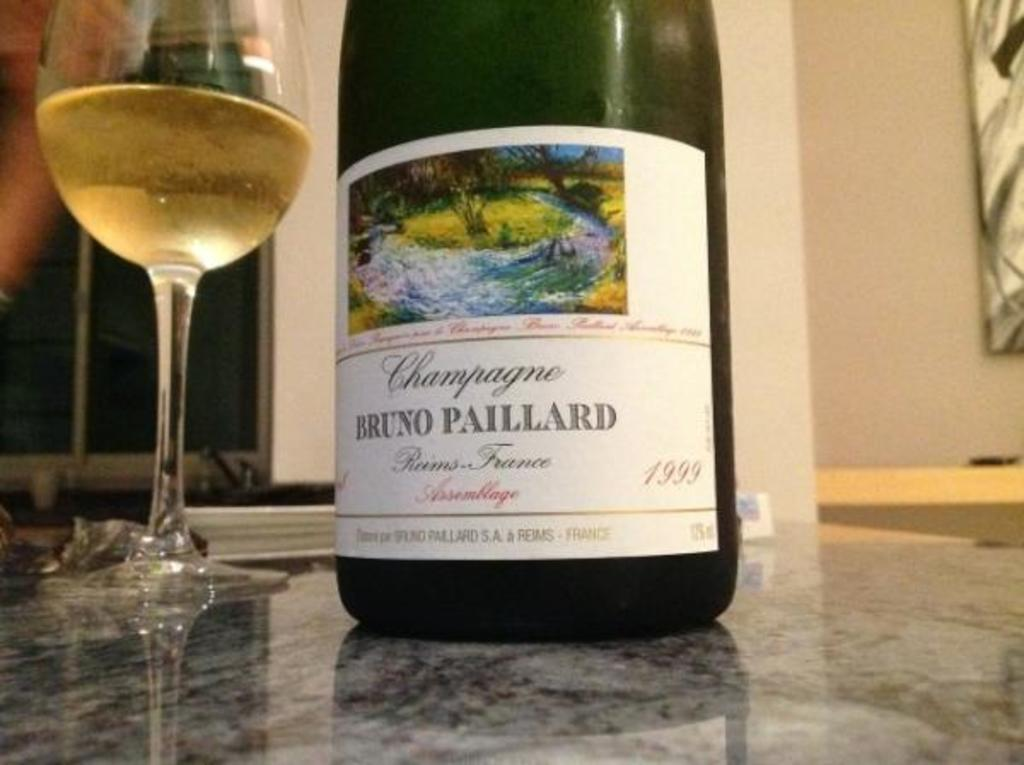<image>
Give a short and clear explanation of the subsequent image. Bottle of wine that has the wording on it, saying Champagne Bruno Paillard 1993. 